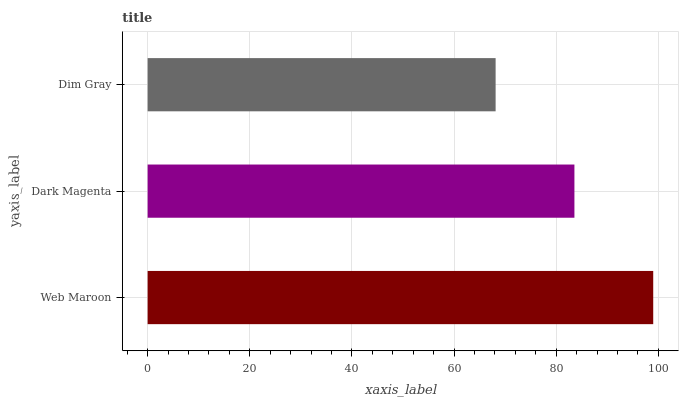Is Dim Gray the minimum?
Answer yes or no. Yes. Is Web Maroon the maximum?
Answer yes or no. Yes. Is Dark Magenta the minimum?
Answer yes or no. No. Is Dark Magenta the maximum?
Answer yes or no. No. Is Web Maroon greater than Dark Magenta?
Answer yes or no. Yes. Is Dark Magenta less than Web Maroon?
Answer yes or no. Yes. Is Dark Magenta greater than Web Maroon?
Answer yes or no. No. Is Web Maroon less than Dark Magenta?
Answer yes or no. No. Is Dark Magenta the high median?
Answer yes or no. Yes. Is Dark Magenta the low median?
Answer yes or no. Yes. Is Web Maroon the high median?
Answer yes or no. No. Is Dim Gray the low median?
Answer yes or no. No. 